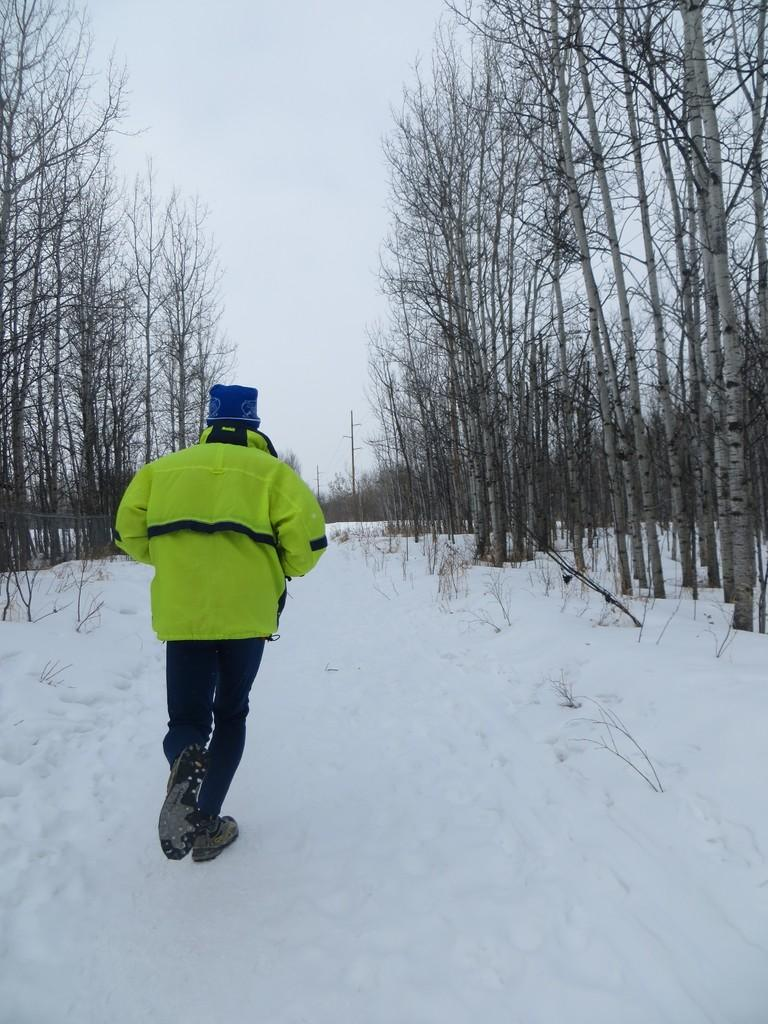What is the main subject of the image? There is a person in the image. What type of clothing is the person wearing? The person is wearing a jacket and shoes. What is the person doing in the image? The person is walking on snow. What can be seen on either side of the person? There are dry trees on either side of the person. What is visible above the scene? The sky is visible above the scene. What type of vase can be seen in the image? There is no vase present in the image. What does the person's voice sound like in the image? The image is a still photograph, so there is no sound or voice present. 